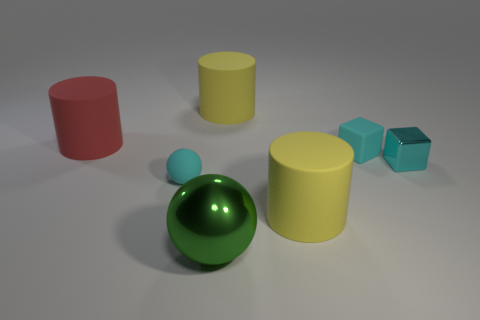There is a tiny cyan thing that is made of the same material as the big green ball; what is its shape?
Give a very brief answer. Cube. What is the color of the object in front of the large yellow matte cylinder in front of the large object that is behind the large red matte cylinder?
Give a very brief answer. Green. Are there the same number of green metal spheres on the right side of the big green ball and tiny yellow things?
Make the answer very short. Yes. Does the small ball have the same color as the rubber cube to the right of the large ball?
Give a very brief answer. Yes. There is a big yellow cylinder that is behind the metallic object that is to the right of the big sphere; is there a small cyan matte sphere in front of it?
Offer a terse response. Yes. Is the number of tiny cyan metal objects in front of the tiny cyan ball less than the number of matte cylinders?
Make the answer very short. Yes. How many other things are the same shape as the big green shiny object?
Keep it short and to the point. 1. How many objects are either yellow objects behind the tiny metal cube or large yellow matte cylinders in front of the big red matte object?
Your answer should be very brief. 2. How big is the object that is on the left side of the green object and in front of the cyan shiny object?
Your answer should be very brief. Small. Does the big yellow object in front of the large red matte cylinder have the same shape as the cyan metallic object?
Provide a short and direct response. No. 